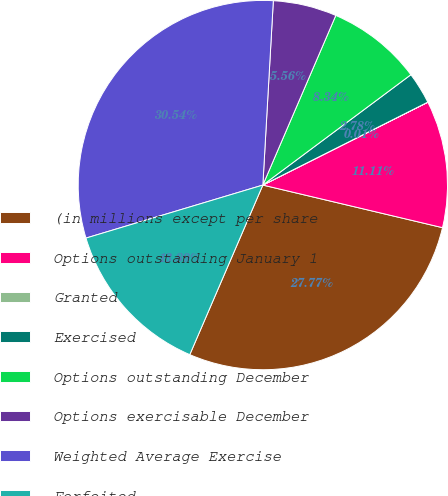Convert chart to OTSL. <chart><loc_0><loc_0><loc_500><loc_500><pie_chart><fcel>(in millions except per share<fcel>Options outstanding January 1<fcel>Granted<fcel>Exercised<fcel>Options outstanding December<fcel>Options exercisable December<fcel>Weighted Average Exercise<fcel>Forfeited<nl><fcel>27.77%<fcel>11.11%<fcel>0.01%<fcel>2.78%<fcel>8.34%<fcel>5.56%<fcel>30.54%<fcel>13.89%<nl></chart> 